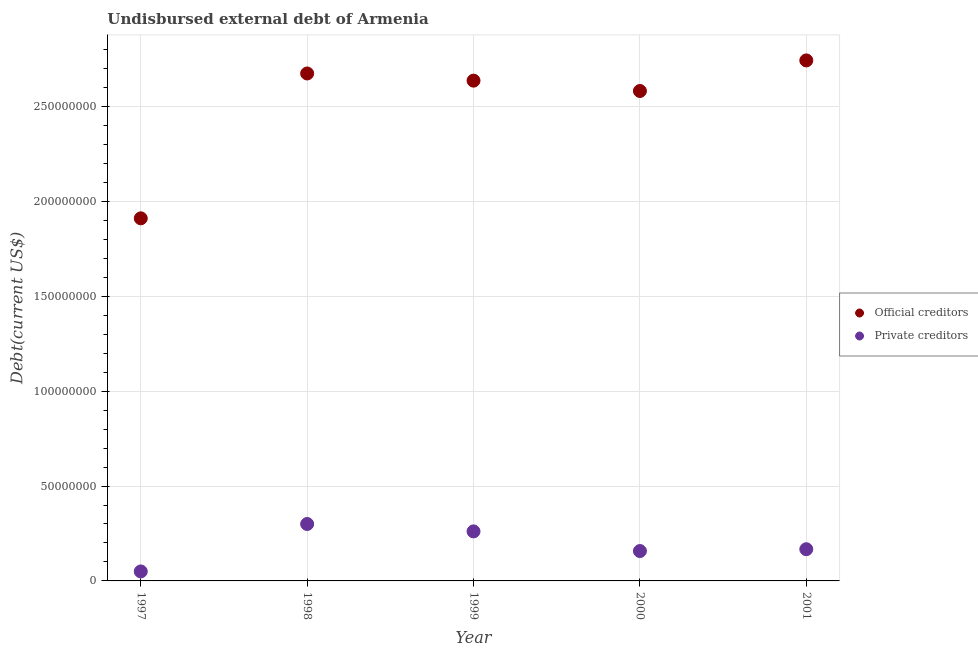Is the number of dotlines equal to the number of legend labels?
Your answer should be compact. Yes. What is the undisbursed external debt of official creditors in 1999?
Provide a succinct answer. 2.64e+08. Across all years, what is the maximum undisbursed external debt of official creditors?
Provide a short and direct response. 2.74e+08. Across all years, what is the minimum undisbursed external debt of official creditors?
Offer a very short reply. 1.91e+08. In which year was the undisbursed external debt of private creditors minimum?
Your response must be concise. 1997. What is the total undisbursed external debt of private creditors in the graph?
Keep it short and to the point. 9.36e+07. What is the difference between the undisbursed external debt of private creditors in 1997 and that in 2001?
Your answer should be very brief. -1.17e+07. What is the difference between the undisbursed external debt of official creditors in 1999 and the undisbursed external debt of private creditors in 1998?
Provide a succinct answer. 2.34e+08. What is the average undisbursed external debt of private creditors per year?
Make the answer very short. 1.87e+07. In the year 1999, what is the difference between the undisbursed external debt of private creditors and undisbursed external debt of official creditors?
Ensure brevity in your answer.  -2.38e+08. What is the ratio of the undisbursed external debt of private creditors in 1998 to that in 1999?
Give a very brief answer. 1.15. Is the undisbursed external debt of official creditors in 1997 less than that in 1999?
Keep it short and to the point. Yes. Is the difference between the undisbursed external debt of private creditors in 1998 and 2001 greater than the difference between the undisbursed external debt of official creditors in 1998 and 2001?
Offer a terse response. Yes. What is the difference between the highest and the second highest undisbursed external debt of private creditors?
Offer a very short reply. 3.90e+06. What is the difference between the highest and the lowest undisbursed external debt of private creditors?
Offer a very short reply. 2.50e+07. In how many years, is the undisbursed external debt of private creditors greater than the average undisbursed external debt of private creditors taken over all years?
Provide a short and direct response. 2. Does the undisbursed external debt of private creditors monotonically increase over the years?
Your response must be concise. No. Is the undisbursed external debt of private creditors strictly greater than the undisbursed external debt of official creditors over the years?
Make the answer very short. No. What is the difference between two consecutive major ticks on the Y-axis?
Provide a succinct answer. 5.00e+07. Are the values on the major ticks of Y-axis written in scientific E-notation?
Keep it short and to the point. No. Does the graph contain any zero values?
Your answer should be compact. No. Does the graph contain grids?
Ensure brevity in your answer.  Yes. How are the legend labels stacked?
Offer a terse response. Vertical. What is the title of the graph?
Your answer should be compact. Undisbursed external debt of Armenia. What is the label or title of the X-axis?
Ensure brevity in your answer.  Year. What is the label or title of the Y-axis?
Offer a very short reply. Debt(current US$). What is the Debt(current US$) in Official creditors in 1997?
Ensure brevity in your answer.  1.91e+08. What is the Debt(current US$) in Official creditors in 1998?
Give a very brief answer. 2.67e+08. What is the Debt(current US$) in Private creditors in 1998?
Keep it short and to the point. 3.00e+07. What is the Debt(current US$) of Official creditors in 1999?
Your response must be concise. 2.64e+08. What is the Debt(current US$) of Private creditors in 1999?
Give a very brief answer. 2.61e+07. What is the Debt(current US$) of Official creditors in 2000?
Give a very brief answer. 2.58e+08. What is the Debt(current US$) in Private creditors in 2000?
Provide a short and direct response. 1.58e+07. What is the Debt(current US$) in Official creditors in 2001?
Your answer should be compact. 2.74e+08. What is the Debt(current US$) in Private creditors in 2001?
Give a very brief answer. 1.67e+07. Across all years, what is the maximum Debt(current US$) in Official creditors?
Your answer should be very brief. 2.74e+08. Across all years, what is the maximum Debt(current US$) in Private creditors?
Give a very brief answer. 3.00e+07. Across all years, what is the minimum Debt(current US$) in Official creditors?
Your answer should be very brief. 1.91e+08. Across all years, what is the minimum Debt(current US$) in Private creditors?
Ensure brevity in your answer.  5.00e+06. What is the total Debt(current US$) in Official creditors in the graph?
Your answer should be very brief. 1.25e+09. What is the total Debt(current US$) in Private creditors in the graph?
Give a very brief answer. 9.36e+07. What is the difference between the Debt(current US$) of Official creditors in 1997 and that in 1998?
Keep it short and to the point. -7.63e+07. What is the difference between the Debt(current US$) of Private creditors in 1997 and that in 1998?
Ensure brevity in your answer.  -2.50e+07. What is the difference between the Debt(current US$) of Official creditors in 1997 and that in 1999?
Your answer should be compact. -7.26e+07. What is the difference between the Debt(current US$) in Private creditors in 1997 and that in 1999?
Your response must be concise. -2.11e+07. What is the difference between the Debt(current US$) in Official creditors in 1997 and that in 2000?
Ensure brevity in your answer.  -6.71e+07. What is the difference between the Debt(current US$) in Private creditors in 1997 and that in 2000?
Give a very brief answer. -1.08e+07. What is the difference between the Debt(current US$) of Official creditors in 1997 and that in 2001?
Make the answer very short. -8.32e+07. What is the difference between the Debt(current US$) in Private creditors in 1997 and that in 2001?
Provide a short and direct response. -1.17e+07. What is the difference between the Debt(current US$) in Official creditors in 1998 and that in 1999?
Your answer should be very brief. 3.78e+06. What is the difference between the Debt(current US$) in Private creditors in 1998 and that in 1999?
Your answer should be very brief. 3.90e+06. What is the difference between the Debt(current US$) in Official creditors in 1998 and that in 2000?
Make the answer very short. 9.23e+06. What is the difference between the Debt(current US$) in Private creditors in 1998 and that in 2000?
Make the answer very short. 1.42e+07. What is the difference between the Debt(current US$) of Official creditors in 1998 and that in 2001?
Your answer should be very brief. -6.88e+06. What is the difference between the Debt(current US$) of Private creditors in 1998 and that in 2001?
Your answer should be compact. 1.33e+07. What is the difference between the Debt(current US$) of Official creditors in 1999 and that in 2000?
Your response must be concise. 5.45e+06. What is the difference between the Debt(current US$) in Private creditors in 1999 and that in 2000?
Offer a very short reply. 1.04e+07. What is the difference between the Debt(current US$) of Official creditors in 1999 and that in 2001?
Keep it short and to the point. -1.07e+07. What is the difference between the Debt(current US$) of Private creditors in 1999 and that in 2001?
Offer a terse response. 9.39e+06. What is the difference between the Debt(current US$) in Official creditors in 2000 and that in 2001?
Keep it short and to the point. -1.61e+07. What is the difference between the Debt(current US$) of Private creditors in 2000 and that in 2001?
Your response must be concise. -9.60e+05. What is the difference between the Debt(current US$) in Official creditors in 1997 and the Debt(current US$) in Private creditors in 1998?
Make the answer very short. 1.61e+08. What is the difference between the Debt(current US$) in Official creditors in 1997 and the Debt(current US$) in Private creditors in 1999?
Ensure brevity in your answer.  1.65e+08. What is the difference between the Debt(current US$) in Official creditors in 1997 and the Debt(current US$) in Private creditors in 2000?
Give a very brief answer. 1.75e+08. What is the difference between the Debt(current US$) of Official creditors in 1997 and the Debt(current US$) of Private creditors in 2001?
Offer a terse response. 1.74e+08. What is the difference between the Debt(current US$) of Official creditors in 1998 and the Debt(current US$) of Private creditors in 1999?
Offer a very short reply. 2.41e+08. What is the difference between the Debt(current US$) in Official creditors in 1998 and the Debt(current US$) in Private creditors in 2000?
Provide a short and direct response. 2.52e+08. What is the difference between the Debt(current US$) in Official creditors in 1998 and the Debt(current US$) in Private creditors in 2001?
Ensure brevity in your answer.  2.51e+08. What is the difference between the Debt(current US$) in Official creditors in 1999 and the Debt(current US$) in Private creditors in 2000?
Your answer should be compact. 2.48e+08. What is the difference between the Debt(current US$) in Official creditors in 1999 and the Debt(current US$) in Private creditors in 2001?
Your answer should be very brief. 2.47e+08. What is the difference between the Debt(current US$) of Official creditors in 2000 and the Debt(current US$) of Private creditors in 2001?
Keep it short and to the point. 2.41e+08. What is the average Debt(current US$) of Official creditors per year?
Ensure brevity in your answer.  2.51e+08. What is the average Debt(current US$) of Private creditors per year?
Ensure brevity in your answer.  1.87e+07. In the year 1997, what is the difference between the Debt(current US$) of Official creditors and Debt(current US$) of Private creditors?
Ensure brevity in your answer.  1.86e+08. In the year 1998, what is the difference between the Debt(current US$) in Official creditors and Debt(current US$) in Private creditors?
Provide a succinct answer. 2.37e+08. In the year 1999, what is the difference between the Debt(current US$) of Official creditors and Debt(current US$) of Private creditors?
Your answer should be compact. 2.38e+08. In the year 2000, what is the difference between the Debt(current US$) in Official creditors and Debt(current US$) in Private creditors?
Your response must be concise. 2.42e+08. In the year 2001, what is the difference between the Debt(current US$) in Official creditors and Debt(current US$) in Private creditors?
Give a very brief answer. 2.58e+08. What is the ratio of the Debt(current US$) of Official creditors in 1997 to that in 1998?
Provide a succinct answer. 0.71. What is the ratio of the Debt(current US$) of Official creditors in 1997 to that in 1999?
Your response must be concise. 0.72. What is the ratio of the Debt(current US$) in Private creditors in 1997 to that in 1999?
Make the answer very short. 0.19. What is the ratio of the Debt(current US$) in Official creditors in 1997 to that in 2000?
Keep it short and to the point. 0.74. What is the ratio of the Debt(current US$) of Private creditors in 1997 to that in 2000?
Offer a terse response. 0.32. What is the ratio of the Debt(current US$) of Official creditors in 1997 to that in 2001?
Offer a terse response. 0.7. What is the ratio of the Debt(current US$) in Private creditors in 1997 to that in 2001?
Your answer should be very brief. 0.3. What is the ratio of the Debt(current US$) of Official creditors in 1998 to that in 1999?
Provide a succinct answer. 1.01. What is the ratio of the Debt(current US$) in Private creditors in 1998 to that in 1999?
Provide a short and direct response. 1.15. What is the ratio of the Debt(current US$) in Official creditors in 1998 to that in 2000?
Your answer should be compact. 1.04. What is the ratio of the Debt(current US$) in Private creditors in 1998 to that in 2000?
Your answer should be compact. 1.9. What is the ratio of the Debt(current US$) in Official creditors in 1998 to that in 2001?
Provide a succinct answer. 0.97. What is the ratio of the Debt(current US$) in Private creditors in 1998 to that in 2001?
Your response must be concise. 1.8. What is the ratio of the Debt(current US$) in Official creditors in 1999 to that in 2000?
Your response must be concise. 1.02. What is the ratio of the Debt(current US$) of Private creditors in 1999 to that in 2000?
Offer a terse response. 1.66. What is the ratio of the Debt(current US$) in Official creditors in 1999 to that in 2001?
Your response must be concise. 0.96. What is the ratio of the Debt(current US$) of Private creditors in 1999 to that in 2001?
Make the answer very short. 1.56. What is the ratio of the Debt(current US$) of Official creditors in 2000 to that in 2001?
Keep it short and to the point. 0.94. What is the ratio of the Debt(current US$) in Private creditors in 2000 to that in 2001?
Your answer should be very brief. 0.94. What is the difference between the highest and the second highest Debt(current US$) in Official creditors?
Your response must be concise. 6.88e+06. What is the difference between the highest and the second highest Debt(current US$) in Private creditors?
Your response must be concise. 3.90e+06. What is the difference between the highest and the lowest Debt(current US$) in Official creditors?
Your answer should be very brief. 8.32e+07. What is the difference between the highest and the lowest Debt(current US$) of Private creditors?
Your answer should be very brief. 2.50e+07. 